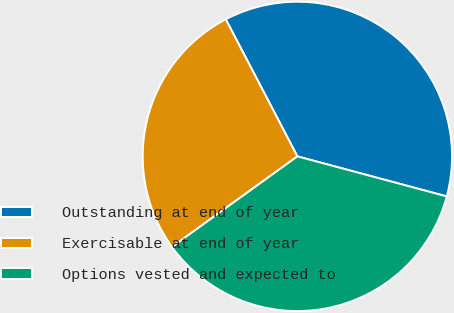Convert chart to OTSL. <chart><loc_0><loc_0><loc_500><loc_500><pie_chart><fcel>Outstanding at end of year<fcel>Exercisable at end of year<fcel>Options vested and expected to<nl><fcel>36.83%<fcel>27.29%<fcel>35.88%<nl></chart> 